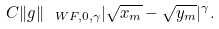<formula> <loc_0><loc_0><loc_500><loc_500>C \| g \| _ { \ W F , 0 , \gamma } | \sqrt { x _ { m } } - \sqrt { y _ { m } } | ^ { \gamma } .</formula> 